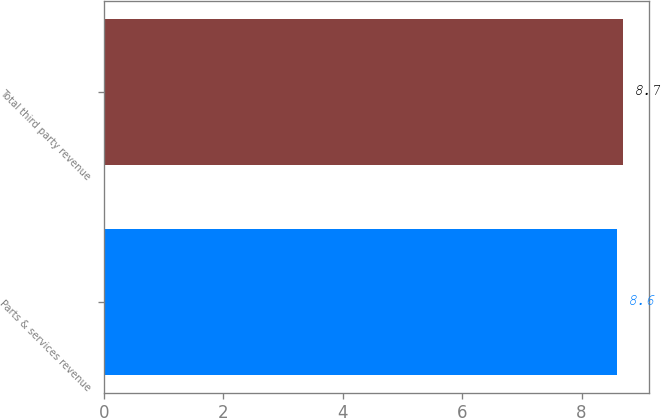<chart> <loc_0><loc_0><loc_500><loc_500><bar_chart><fcel>Parts & services revenue<fcel>Total third party revenue<nl><fcel>8.6<fcel>8.7<nl></chart> 